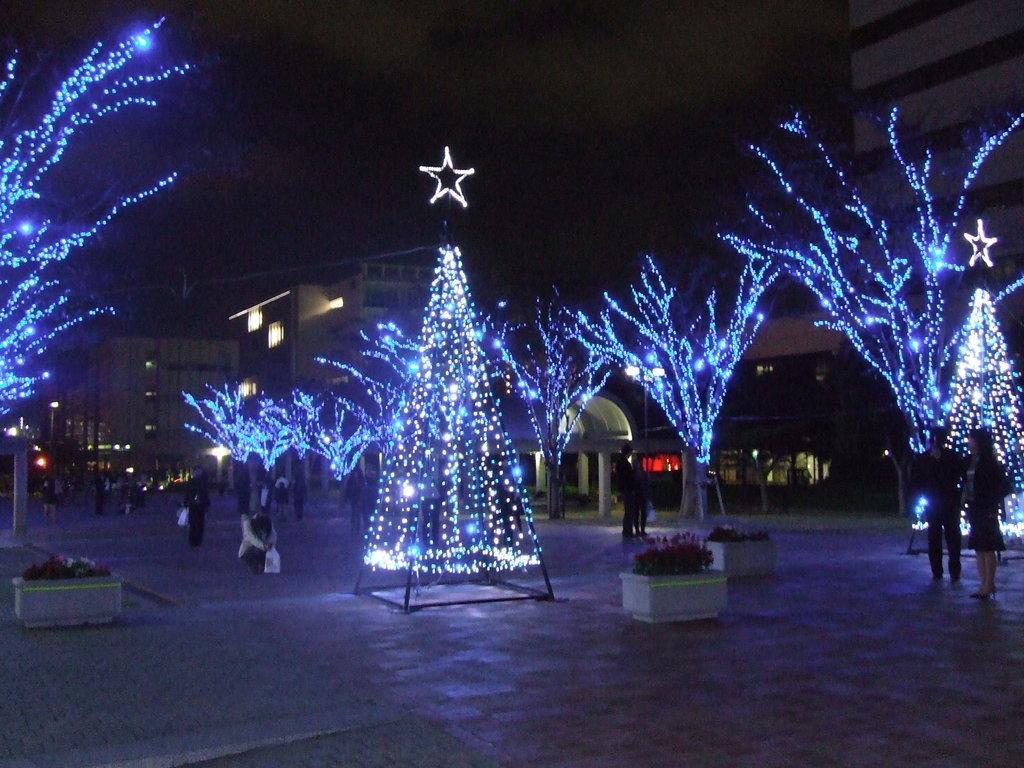Can you describe this image briefly? In this image, I can see a couple of trees which is colored with full of lights and towards right corner two people standing and towards left walking and holding also i can see a window, building, a street poles which includes lights and few flower pots. 